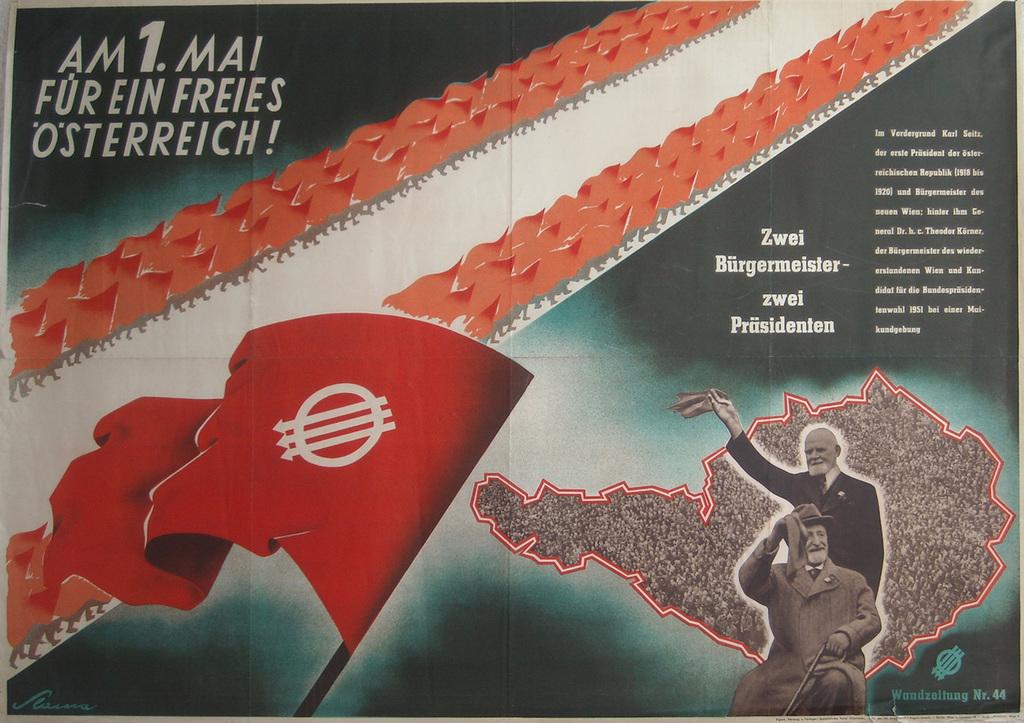What language is present in the ad?
Your answer should be compact. Unanswerable. What number is in the top left?
Provide a short and direct response. 1. 